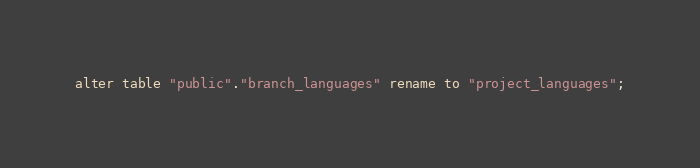Convert code to text. <code><loc_0><loc_0><loc_500><loc_500><_SQL_>alter table "public"."branch_languages" rename to "project_languages";
</code> 